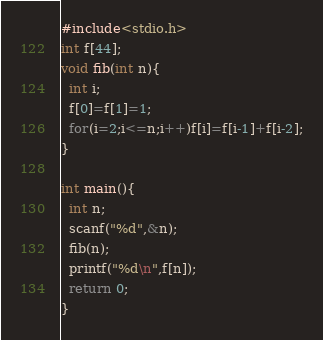Convert code to text. <code><loc_0><loc_0><loc_500><loc_500><_C_>#include<stdio.h>
int f[44];
void fib(int n){
  int i;
  f[0]=f[1]=1;
  for(i=2;i<=n;i++)f[i]=f[i-1]+f[i-2];
}

int main(){
  int n;
  scanf("%d",&n);
  fib(n);
  printf("%d\n",f[n]);
  return 0;
}

</code> 